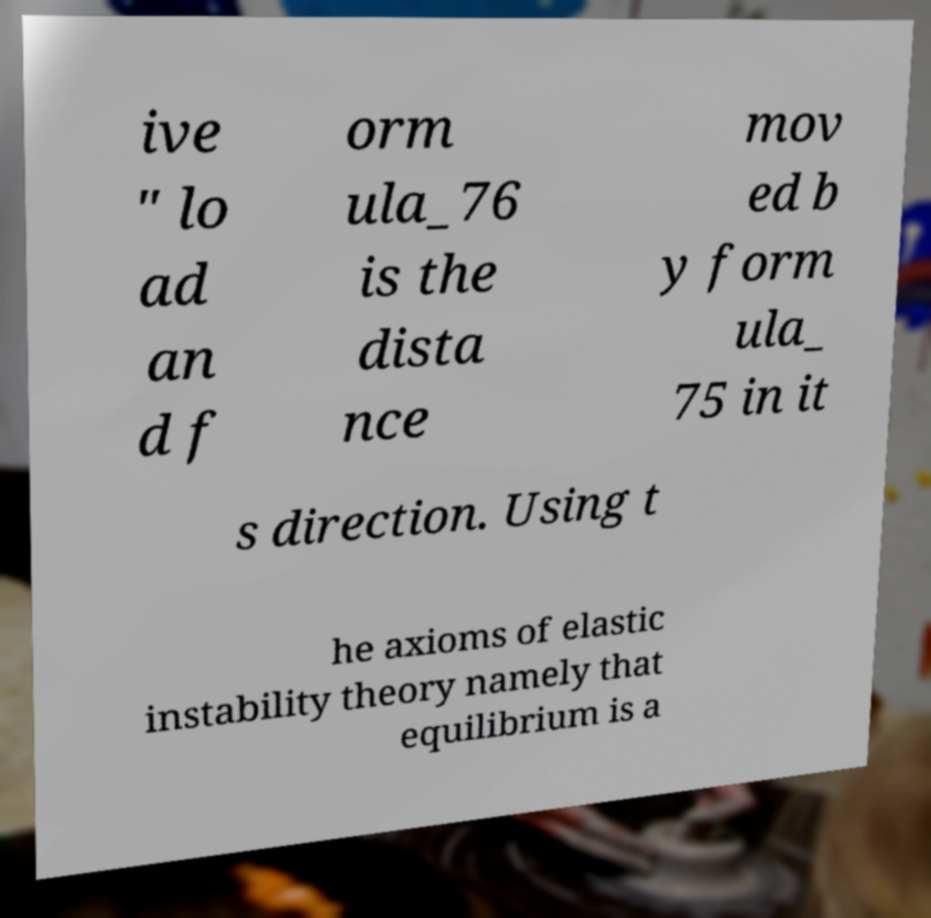For documentation purposes, I need the text within this image transcribed. Could you provide that? ive " lo ad an d f orm ula_76 is the dista nce mov ed b y form ula_ 75 in it s direction. Using t he axioms of elastic instability theory namely that equilibrium is a 